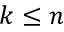Convert formula to latex. <formula><loc_0><loc_0><loc_500><loc_500>k \leq n</formula> 